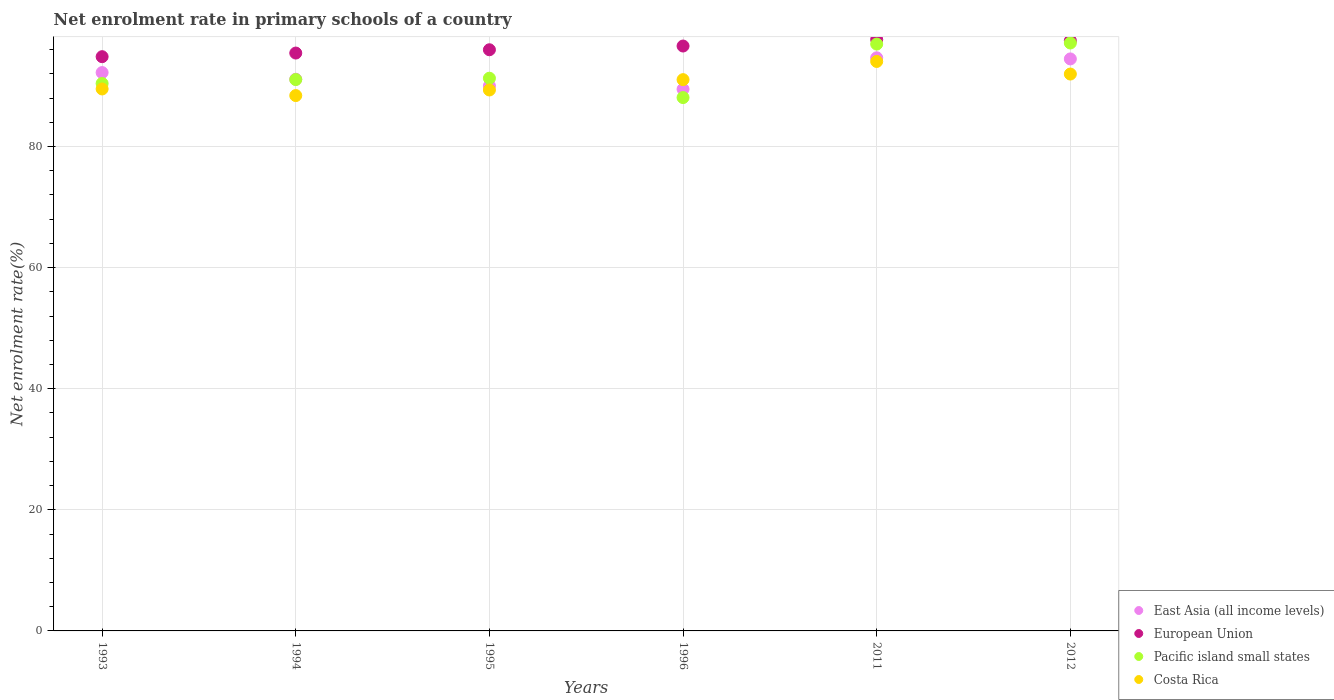Is the number of dotlines equal to the number of legend labels?
Your response must be concise. Yes. What is the net enrolment rate in primary schools in Pacific island small states in 1996?
Make the answer very short. 88.09. Across all years, what is the maximum net enrolment rate in primary schools in Costa Rica?
Your response must be concise. 94.06. Across all years, what is the minimum net enrolment rate in primary schools in European Union?
Provide a short and direct response. 94.84. In which year was the net enrolment rate in primary schools in East Asia (all income levels) maximum?
Provide a short and direct response. 2011. In which year was the net enrolment rate in primary schools in East Asia (all income levels) minimum?
Give a very brief answer. 1996. What is the total net enrolment rate in primary schools in East Asia (all income levels) in the graph?
Provide a short and direct response. 551.97. What is the difference between the net enrolment rate in primary schools in East Asia (all income levels) in 1993 and that in 2012?
Keep it short and to the point. -2.25. What is the difference between the net enrolment rate in primary schools in East Asia (all income levels) in 1993 and the net enrolment rate in primary schools in European Union in 1994?
Make the answer very short. -3.22. What is the average net enrolment rate in primary schools in East Asia (all income levels) per year?
Ensure brevity in your answer.  91.99. In the year 1996, what is the difference between the net enrolment rate in primary schools in East Asia (all income levels) and net enrolment rate in primary schools in Pacific island small states?
Give a very brief answer. 1.38. What is the ratio of the net enrolment rate in primary schools in East Asia (all income levels) in 1996 to that in 2011?
Give a very brief answer. 0.95. Is the net enrolment rate in primary schools in Costa Rica in 1993 less than that in 1994?
Provide a short and direct response. No. Is the difference between the net enrolment rate in primary schools in East Asia (all income levels) in 1993 and 1994 greater than the difference between the net enrolment rate in primary schools in Pacific island small states in 1993 and 1994?
Make the answer very short. Yes. What is the difference between the highest and the second highest net enrolment rate in primary schools in East Asia (all income levels)?
Give a very brief answer. 0.18. What is the difference between the highest and the lowest net enrolment rate in primary schools in Pacific island small states?
Provide a succinct answer. 9.01. In how many years, is the net enrolment rate in primary schools in Pacific island small states greater than the average net enrolment rate in primary schools in Pacific island small states taken over all years?
Your response must be concise. 2. Is the sum of the net enrolment rate in primary schools in Pacific island small states in 1993 and 2011 greater than the maximum net enrolment rate in primary schools in Costa Rica across all years?
Your answer should be compact. Yes. Is it the case that in every year, the sum of the net enrolment rate in primary schools in Pacific island small states and net enrolment rate in primary schools in Costa Rica  is greater than the net enrolment rate in primary schools in East Asia (all income levels)?
Your answer should be compact. Yes. Is the net enrolment rate in primary schools in European Union strictly greater than the net enrolment rate in primary schools in East Asia (all income levels) over the years?
Give a very brief answer. Yes. How many dotlines are there?
Ensure brevity in your answer.  4. Does the graph contain grids?
Make the answer very short. Yes. Where does the legend appear in the graph?
Your answer should be very brief. Bottom right. How are the legend labels stacked?
Ensure brevity in your answer.  Vertical. What is the title of the graph?
Make the answer very short. Net enrolment rate in primary schools of a country. What is the label or title of the X-axis?
Offer a terse response. Years. What is the label or title of the Y-axis?
Your answer should be compact. Net enrolment rate(%). What is the Net enrolment rate(%) of East Asia (all income levels) in 1993?
Ensure brevity in your answer.  92.22. What is the Net enrolment rate(%) in European Union in 1993?
Keep it short and to the point. 94.84. What is the Net enrolment rate(%) of Pacific island small states in 1993?
Make the answer very short. 90.42. What is the Net enrolment rate(%) in Costa Rica in 1993?
Give a very brief answer. 89.51. What is the Net enrolment rate(%) of East Asia (all income levels) in 1994?
Make the answer very short. 91.12. What is the Net enrolment rate(%) in European Union in 1994?
Provide a succinct answer. 95.44. What is the Net enrolment rate(%) in Pacific island small states in 1994?
Keep it short and to the point. 91.07. What is the Net enrolment rate(%) of Costa Rica in 1994?
Provide a succinct answer. 88.42. What is the Net enrolment rate(%) of East Asia (all income levels) in 1995?
Offer a very short reply. 90.02. What is the Net enrolment rate(%) of European Union in 1995?
Keep it short and to the point. 95.99. What is the Net enrolment rate(%) in Pacific island small states in 1995?
Keep it short and to the point. 91.29. What is the Net enrolment rate(%) in Costa Rica in 1995?
Give a very brief answer. 89.34. What is the Net enrolment rate(%) in East Asia (all income levels) in 1996?
Your answer should be very brief. 89.47. What is the Net enrolment rate(%) in European Union in 1996?
Make the answer very short. 96.6. What is the Net enrolment rate(%) in Pacific island small states in 1996?
Keep it short and to the point. 88.09. What is the Net enrolment rate(%) of Costa Rica in 1996?
Give a very brief answer. 91.05. What is the Net enrolment rate(%) in East Asia (all income levels) in 2011?
Your answer should be compact. 94.66. What is the Net enrolment rate(%) of European Union in 2011?
Keep it short and to the point. 97.69. What is the Net enrolment rate(%) in Pacific island small states in 2011?
Keep it short and to the point. 96.93. What is the Net enrolment rate(%) of Costa Rica in 2011?
Your answer should be very brief. 94.06. What is the Net enrolment rate(%) in East Asia (all income levels) in 2012?
Your answer should be very brief. 94.48. What is the Net enrolment rate(%) of European Union in 2012?
Provide a succinct answer. 97.48. What is the Net enrolment rate(%) in Pacific island small states in 2012?
Make the answer very short. 97.1. What is the Net enrolment rate(%) in Costa Rica in 2012?
Your response must be concise. 91.98. Across all years, what is the maximum Net enrolment rate(%) in East Asia (all income levels)?
Ensure brevity in your answer.  94.66. Across all years, what is the maximum Net enrolment rate(%) in European Union?
Your response must be concise. 97.69. Across all years, what is the maximum Net enrolment rate(%) of Pacific island small states?
Your answer should be compact. 97.1. Across all years, what is the maximum Net enrolment rate(%) in Costa Rica?
Make the answer very short. 94.06. Across all years, what is the minimum Net enrolment rate(%) in East Asia (all income levels)?
Keep it short and to the point. 89.47. Across all years, what is the minimum Net enrolment rate(%) of European Union?
Your answer should be compact. 94.84. Across all years, what is the minimum Net enrolment rate(%) of Pacific island small states?
Keep it short and to the point. 88.09. Across all years, what is the minimum Net enrolment rate(%) of Costa Rica?
Your answer should be very brief. 88.42. What is the total Net enrolment rate(%) in East Asia (all income levels) in the graph?
Your response must be concise. 551.97. What is the total Net enrolment rate(%) in European Union in the graph?
Provide a short and direct response. 578.04. What is the total Net enrolment rate(%) of Pacific island small states in the graph?
Offer a terse response. 554.9. What is the total Net enrolment rate(%) in Costa Rica in the graph?
Make the answer very short. 544.36. What is the difference between the Net enrolment rate(%) of East Asia (all income levels) in 1993 and that in 1994?
Ensure brevity in your answer.  1.1. What is the difference between the Net enrolment rate(%) in European Union in 1993 and that in 1994?
Keep it short and to the point. -0.6. What is the difference between the Net enrolment rate(%) of Pacific island small states in 1993 and that in 1994?
Your response must be concise. -0.65. What is the difference between the Net enrolment rate(%) of Costa Rica in 1993 and that in 1994?
Your response must be concise. 1.09. What is the difference between the Net enrolment rate(%) in European Union in 1993 and that in 1995?
Provide a succinct answer. -1.14. What is the difference between the Net enrolment rate(%) in Pacific island small states in 1993 and that in 1995?
Offer a very short reply. -0.87. What is the difference between the Net enrolment rate(%) of Costa Rica in 1993 and that in 1995?
Provide a short and direct response. 0.17. What is the difference between the Net enrolment rate(%) in East Asia (all income levels) in 1993 and that in 1996?
Provide a succinct answer. 2.75. What is the difference between the Net enrolment rate(%) of European Union in 1993 and that in 1996?
Make the answer very short. -1.76. What is the difference between the Net enrolment rate(%) in Pacific island small states in 1993 and that in 1996?
Your response must be concise. 2.33. What is the difference between the Net enrolment rate(%) of Costa Rica in 1993 and that in 1996?
Provide a succinct answer. -1.54. What is the difference between the Net enrolment rate(%) of East Asia (all income levels) in 1993 and that in 2011?
Offer a very short reply. -2.44. What is the difference between the Net enrolment rate(%) in European Union in 1993 and that in 2011?
Give a very brief answer. -2.84. What is the difference between the Net enrolment rate(%) of Pacific island small states in 1993 and that in 2011?
Your answer should be very brief. -6.51. What is the difference between the Net enrolment rate(%) of Costa Rica in 1993 and that in 2011?
Provide a short and direct response. -4.54. What is the difference between the Net enrolment rate(%) in East Asia (all income levels) in 1993 and that in 2012?
Provide a succinct answer. -2.25. What is the difference between the Net enrolment rate(%) in European Union in 1993 and that in 2012?
Provide a succinct answer. -2.64. What is the difference between the Net enrolment rate(%) in Pacific island small states in 1993 and that in 2012?
Ensure brevity in your answer.  -6.68. What is the difference between the Net enrolment rate(%) of Costa Rica in 1993 and that in 2012?
Make the answer very short. -2.46. What is the difference between the Net enrolment rate(%) of East Asia (all income levels) in 1994 and that in 1995?
Keep it short and to the point. 1.1. What is the difference between the Net enrolment rate(%) of European Union in 1994 and that in 1995?
Provide a succinct answer. -0.54. What is the difference between the Net enrolment rate(%) in Pacific island small states in 1994 and that in 1995?
Your response must be concise. -0.22. What is the difference between the Net enrolment rate(%) of Costa Rica in 1994 and that in 1995?
Offer a terse response. -0.92. What is the difference between the Net enrolment rate(%) of East Asia (all income levels) in 1994 and that in 1996?
Offer a very short reply. 1.65. What is the difference between the Net enrolment rate(%) in European Union in 1994 and that in 1996?
Keep it short and to the point. -1.16. What is the difference between the Net enrolment rate(%) in Pacific island small states in 1994 and that in 1996?
Offer a very short reply. 2.97. What is the difference between the Net enrolment rate(%) of Costa Rica in 1994 and that in 1996?
Offer a terse response. -2.63. What is the difference between the Net enrolment rate(%) in East Asia (all income levels) in 1994 and that in 2011?
Your answer should be very brief. -3.54. What is the difference between the Net enrolment rate(%) in European Union in 1994 and that in 2011?
Ensure brevity in your answer.  -2.24. What is the difference between the Net enrolment rate(%) of Pacific island small states in 1994 and that in 2011?
Your answer should be compact. -5.86. What is the difference between the Net enrolment rate(%) in Costa Rica in 1994 and that in 2011?
Provide a succinct answer. -5.63. What is the difference between the Net enrolment rate(%) in East Asia (all income levels) in 1994 and that in 2012?
Give a very brief answer. -3.35. What is the difference between the Net enrolment rate(%) of European Union in 1994 and that in 2012?
Your response must be concise. -2.04. What is the difference between the Net enrolment rate(%) of Pacific island small states in 1994 and that in 2012?
Offer a terse response. -6.04. What is the difference between the Net enrolment rate(%) of Costa Rica in 1994 and that in 2012?
Make the answer very short. -3.55. What is the difference between the Net enrolment rate(%) of East Asia (all income levels) in 1995 and that in 1996?
Ensure brevity in your answer.  0.55. What is the difference between the Net enrolment rate(%) of European Union in 1995 and that in 1996?
Provide a short and direct response. -0.62. What is the difference between the Net enrolment rate(%) of Pacific island small states in 1995 and that in 1996?
Your answer should be compact. 3.2. What is the difference between the Net enrolment rate(%) of Costa Rica in 1995 and that in 1996?
Give a very brief answer. -1.71. What is the difference between the Net enrolment rate(%) of East Asia (all income levels) in 1995 and that in 2011?
Offer a very short reply. -4.64. What is the difference between the Net enrolment rate(%) in European Union in 1995 and that in 2011?
Provide a succinct answer. -1.7. What is the difference between the Net enrolment rate(%) in Pacific island small states in 1995 and that in 2011?
Ensure brevity in your answer.  -5.64. What is the difference between the Net enrolment rate(%) of Costa Rica in 1995 and that in 2011?
Give a very brief answer. -4.71. What is the difference between the Net enrolment rate(%) in East Asia (all income levels) in 1995 and that in 2012?
Your response must be concise. -4.45. What is the difference between the Net enrolment rate(%) of European Union in 1995 and that in 2012?
Offer a terse response. -1.5. What is the difference between the Net enrolment rate(%) of Pacific island small states in 1995 and that in 2012?
Your answer should be compact. -5.82. What is the difference between the Net enrolment rate(%) of Costa Rica in 1995 and that in 2012?
Provide a short and direct response. -2.63. What is the difference between the Net enrolment rate(%) in East Asia (all income levels) in 1996 and that in 2011?
Your answer should be very brief. -5.18. What is the difference between the Net enrolment rate(%) of European Union in 1996 and that in 2011?
Offer a terse response. -1.08. What is the difference between the Net enrolment rate(%) in Pacific island small states in 1996 and that in 2011?
Ensure brevity in your answer.  -8.84. What is the difference between the Net enrolment rate(%) of Costa Rica in 1996 and that in 2011?
Offer a terse response. -3. What is the difference between the Net enrolment rate(%) of East Asia (all income levels) in 1996 and that in 2012?
Offer a very short reply. -5. What is the difference between the Net enrolment rate(%) of European Union in 1996 and that in 2012?
Ensure brevity in your answer.  -0.88. What is the difference between the Net enrolment rate(%) in Pacific island small states in 1996 and that in 2012?
Your response must be concise. -9.01. What is the difference between the Net enrolment rate(%) of Costa Rica in 1996 and that in 2012?
Make the answer very short. -0.92. What is the difference between the Net enrolment rate(%) in East Asia (all income levels) in 2011 and that in 2012?
Your answer should be very brief. 0.18. What is the difference between the Net enrolment rate(%) of European Union in 2011 and that in 2012?
Your response must be concise. 0.2. What is the difference between the Net enrolment rate(%) in Pacific island small states in 2011 and that in 2012?
Your response must be concise. -0.18. What is the difference between the Net enrolment rate(%) of Costa Rica in 2011 and that in 2012?
Your answer should be very brief. 2.08. What is the difference between the Net enrolment rate(%) in East Asia (all income levels) in 1993 and the Net enrolment rate(%) in European Union in 1994?
Provide a succinct answer. -3.22. What is the difference between the Net enrolment rate(%) in East Asia (all income levels) in 1993 and the Net enrolment rate(%) in Pacific island small states in 1994?
Your answer should be very brief. 1.16. What is the difference between the Net enrolment rate(%) in East Asia (all income levels) in 1993 and the Net enrolment rate(%) in Costa Rica in 1994?
Your answer should be very brief. 3.8. What is the difference between the Net enrolment rate(%) of European Union in 1993 and the Net enrolment rate(%) of Pacific island small states in 1994?
Ensure brevity in your answer.  3.78. What is the difference between the Net enrolment rate(%) of European Union in 1993 and the Net enrolment rate(%) of Costa Rica in 1994?
Ensure brevity in your answer.  6.42. What is the difference between the Net enrolment rate(%) of Pacific island small states in 1993 and the Net enrolment rate(%) of Costa Rica in 1994?
Provide a short and direct response. 2. What is the difference between the Net enrolment rate(%) of East Asia (all income levels) in 1993 and the Net enrolment rate(%) of European Union in 1995?
Give a very brief answer. -3.77. What is the difference between the Net enrolment rate(%) in East Asia (all income levels) in 1993 and the Net enrolment rate(%) in Pacific island small states in 1995?
Your answer should be very brief. 0.93. What is the difference between the Net enrolment rate(%) of East Asia (all income levels) in 1993 and the Net enrolment rate(%) of Costa Rica in 1995?
Give a very brief answer. 2.88. What is the difference between the Net enrolment rate(%) of European Union in 1993 and the Net enrolment rate(%) of Pacific island small states in 1995?
Ensure brevity in your answer.  3.56. What is the difference between the Net enrolment rate(%) of European Union in 1993 and the Net enrolment rate(%) of Costa Rica in 1995?
Provide a succinct answer. 5.5. What is the difference between the Net enrolment rate(%) in Pacific island small states in 1993 and the Net enrolment rate(%) in Costa Rica in 1995?
Keep it short and to the point. 1.08. What is the difference between the Net enrolment rate(%) in East Asia (all income levels) in 1993 and the Net enrolment rate(%) in European Union in 1996?
Keep it short and to the point. -4.38. What is the difference between the Net enrolment rate(%) in East Asia (all income levels) in 1993 and the Net enrolment rate(%) in Pacific island small states in 1996?
Offer a terse response. 4.13. What is the difference between the Net enrolment rate(%) of East Asia (all income levels) in 1993 and the Net enrolment rate(%) of Costa Rica in 1996?
Ensure brevity in your answer.  1.17. What is the difference between the Net enrolment rate(%) in European Union in 1993 and the Net enrolment rate(%) in Pacific island small states in 1996?
Offer a very short reply. 6.75. What is the difference between the Net enrolment rate(%) of European Union in 1993 and the Net enrolment rate(%) of Costa Rica in 1996?
Ensure brevity in your answer.  3.79. What is the difference between the Net enrolment rate(%) of Pacific island small states in 1993 and the Net enrolment rate(%) of Costa Rica in 1996?
Provide a succinct answer. -0.63. What is the difference between the Net enrolment rate(%) of East Asia (all income levels) in 1993 and the Net enrolment rate(%) of European Union in 2011?
Provide a short and direct response. -5.46. What is the difference between the Net enrolment rate(%) in East Asia (all income levels) in 1993 and the Net enrolment rate(%) in Pacific island small states in 2011?
Give a very brief answer. -4.71. What is the difference between the Net enrolment rate(%) in East Asia (all income levels) in 1993 and the Net enrolment rate(%) in Costa Rica in 2011?
Give a very brief answer. -1.83. What is the difference between the Net enrolment rate(%) in European Union in 1993 and the Net enrolment rate(%) in Pacific island small states in 2011?
Give a very brief answer. -2.08. What is the difference between the Net enrolment rate(%) in European Union in 1993 and the Net enrolment rate(%) in Costa Rica in 2011?
Provide a short and direct response. 0.79. What is the difference between the Net enrolment rate(%) in Pacific island small states in 1993 and the Net enrolment rate(%) in Costa Rica in 2011?
Provide a succinct answer. -3.64. What is the difference between the Net enrolment rate(%) in East Asia (all income levels) in 1993 and the Net enrolment rate(%) in European Union in 2012?
Provide a succinct answer. -5.26. What is the difference between the Net enrolment rate(%) of East Asia (all income levels) in 1993 and the Net enrolment rate(%) of Pacific island small states in 2012?
Make the answer very short. -4.88. What is the difference between the Net enrolment rate(%) of East Asia (all income levels) in 1993 and the Net enrolment rate(%) of Costa Rica in 2012?
Offer a very short reply. 0.24. What is the difference between the Net enrolment rate(%) of European Union in 1993 and the Net enrolment rate(%) of Pacific island small states in 2012?
Offer a terse response. -2.26. What is the difference between the Net enrolment rate(%) of European Union in 1993 and the Net enrolment rate(%) of Costa Rica in 2012?
Your answer should be compact. 2.87. What is the difference between the Net enrolment rate(%) in Pacific island small states in 1993 and the Net enrolment rate(%) in Costa Rica in 2012?
Your answer should be very brief. -1.56. What is the difference between the Net enrolment rate(%) in East Asia (all income levels) in 1994 and the Net enrolment rate(%) in European Union in 1995?
Provide a short and direct response. -4.87. What is the difference between the Net enrolment rate(%) in East Asia (all income levels) in 1994 and the Net enrolment rate(%) in Pacific island small states in 1995?
Your answer should be very brief. -0.17. What is the difference between the Net enrolment rate(%) of East Asia (all income levels) in 1994 and the Net enrolment rate(%) of Costa Rica in 1995?
Provide a succinct answer. 1.78. What is the difference between the Net enrolment rate(%) in European Union in 1994 and the Net enrolment rate(%) in Pacific island small states in 1995?
Give a very brief answer. 4.16. What is the difference between the Net enrolment rate(%) in European Union in 1994 and the Net enrolment rate(%) in Costa Rica in 1995?
Give a very brief answer. 6.1. What is the difference between the Net enrolment rate(%) of Pacific island small states in 1994 and the Net enrolment rate(%) of Costa Rica in 1995?
Provide a succinct answer. 1.72. What is the difference between the Net enrolment rate(%) of East Asia (all income levels) in 1994 and the Net enrolment rate(%) of European Union in 1996?
Give a very brief answer. -5.48. What is the difference between the Net enrolment rate(%) of East Asia (all income levels) in 1994 and the Net enrolment rate(%) of Pacific island small states in 1996?
Your response must be concise. 3.03. What is the difference between the Net enrolment rate(%) of East Asia (all income levels) in 1994 and the Net enrolment rate(%) of Costa Rica in 1996?
Provide a short and direct response. 0.07. What is the difference between the Net enrolment rate(%) of European Union in 1994 and the Net enrolment rate(%) of Pacific island small states in 1996?
Offer a terse response. 7.35. What is the difference between the Net enrolment rate(%) in European Union in 1994 and the Net enrolment rate(%) in Costa Rica in 1996?
Offer a very short reply. 4.39. What is the difference between the Net enrolment rate(%) in Pacific island small states in 1994 and the Net enrolment rate(%) in Costa Rica in 1996?
Your response must be concise. 0.01. What is the difference between the Net enrolment rate(%) in East Asia (all income levels) in 1994 and the Net enrolment rate(%) in European Union in 2011?
Make the answer very short. -6.56. What is the difference between the Net enrolment rate(%) in East Asia (all income levels) in 1994 and the Net enrolment rate(%) in Pacific island small states in 2011?
Your answer should be very brief. -5.81. What is the difference between the Net enrolment rate(%) in East Asia (all income levels) in 1994 and the Net enrolment rate(%) in Costa Rica in 2011?
Give a very brief answer. -2.93. What is the difference between the Net enrolment rate(%) of European Union in 1994 and the Net enrolment rate(%) of Pacific island small states in 2011?
Offer a terse response. -1.48. What is the difference between the Net enrolment rate(%) in European Union in 1994 and the Net enrolment rate(%) in Costa Rica in 2011?
Provide a short and direct response. 1.39. What is the difference between the Net enrolment rate(%) of Pacific island small states in 1994 and the Net enrolment rate(%) of Costa Rica in 2011?
Your response must be concise. -2.99. What is the difference between the Net enrolment rate(%) of East Asia (all income levels) in 1994 and the Net enrolment rate(%) of European Union in 2012?
Keep it short and to the point. -6.36. What is the difference between the Net enrolment rate(%) in East Asia (all income levels) in 1994 and the Net enrolment rate(%) in Pacific island small states in 2012?
Keep it short and to the point. -5.98. What is the difference between the Net enrolment rate(%) in East Asia (all income levels) in 1994 and the Net enrolment rate(%) in Costa Rica in 2012?
Your answer should be compact. -0.85. What is the difference between the Net enrolment rate(%) of European Union in 1994 and the Net enrolment rate(%) of Pacific island small states in 2012?
Give a very brief answer. -1.66. What is the difference between the Net enrolment rate(%) in European Union in 1994 and the Net enrolment rate(%) in Costa Rica in 2012?
Ensure brevity in your answer.  3.47. What is the difference between the Net enrolment rate(%) of Pacific island small states in 1994 and the Net enrolment rate(%) of Costa Rica in 2012?
Provide a short and direct response. -0.91. What is the difference between the Net enrolment rate(%) in East Asia (all income levels) in 1995 and the Net enrolment rate(%) in European Union in 1996?
Give a very brief answer. -6.58. What is the difference between the Net enrolment rate(%) in East Asia (all income levels) in 1995 and the Net enrolment rate(%) in Pacific island small states in 1996?
Your response must be concise. 1.93. What is the difference between the Net enrolment rate(%) of East Asia (all income levels) in 1995 and the Net enrolment rate(%) of Costa Rica in 1996?
Your response must be concise. -1.03. What is the difference between the Net enrolment rate(%) in European Union in 1995 and the Net enrolment rate(%) in Pacific island small states in 1996?
Provide a succinct answer. 7.9. What is the difference between the Net enrolment rate(%) in European Union in 1995 and the Net enrolment rate(%) in Costa Rica in 1996?
Your answer should be compact. 4.94. What is the difference between the Net enrolment rate(%) in Pacific island small states in 1995 and the Net enrolment rate(%) in Costa Rica in 1996?
Ensure brevity in your answer.  0.24. What is the difference between the Net enrolment rate(%) in East Asia (all income levels) in 1995 and the Net enrolment rate(%) in European Union in 2011?
Provide a short and direct response. -7.66. What is the difference between the Net enrolment rate(%) in East Asia (all income levels) in 1995 and the Net enrolment rate(%) in Pacific island small states in 2011?
Keep it short and to the point. -6.91. What is the difference between the Net enrolment rate(%) of East Asia (all income levels) in 1995 and the Net enrolment rate(%) of Costa Rica in 2011?
Ensure brevity in your answer.  -4.04. What is the difference between the Net enrolment rate(%) in European Union in 1995 and the Net enrolment rate(%) in Pacific island small states in 2011?
Your answer should be very brief. -0.94. What is the difference between the Net enrolment rate(%) in European Union in 1995 and the Net enrolment rate(%) in Costa Rica in 2011?
Your answer should be very brief. 1.93. What is the difference between the Net enrolment rate(%) of Pacific island small states in 1995 and the Net enrolment rate(%) of Costa Rica in 2011?
Give a very brief answer. -2.77. What is the difference between the Net enrolment rate(%) in East Asia (all income levels) in 1995 and the Net enrolment rate(%) in European Union in 2012?
Make the answer very short. -7.46. What is the difference between the Net enrolment rate(%) of East Asia (all income levels) in 1995 and the Net enrolment rate(%) of Pacific island small states in 2012?
Offer a terse response. -7.08. What is the difference between the Net enrolment rate(%) in East Asia (all income levels) in 1995 and the Net enrolment rate(%) in Costa Rica in 2012?
Keep it short and to the point. -1.96. What is the difference between the Net enrolment rate(%) of European Union in 1995 and the Net enrolment rate(%) of Pacific island small states in 2012?
Give a very brief answer. -1.12. What is the difference between the Net enrolment rate(%) in European Union in 1995 and the Net enrolment rate(%) in Costa Rica in 2012?
Provide a short and direct response. 4.01. What is the difference between the Net enrolment rate(%) in Pacific island small states in 1995 and the Net enrolment rate(%) in Costa Rica in 2012?
Your answer should be very brief. -0.69. What is the difference between the Net enrolment rate(%) in East Asia (all income levels) in 1996 and the Net enrolment rate(%) in European Union in 2011?
Provide a short and direct response. -8.21. What is the difference between the Net enrolment rate(%) in East Asia (all income levels) in 1996 and the Net enrolment rate(%) in Pacific island small states in 2011?
Your response must be concise. -7.45. What is the difference between the Net enrolment rate(%) in East Asia (all income levels) in 1996 and the Net enrolment rate(%) in Costa Rica in 2011?
Ensure brevity in your answer.  -4.58. What is the difference between the Net enrolment rate(%) of European Union in 1996 and the Net enrolment rate(%) of Pacific island small states in 2011?
Give a very brief answer. -0.32. What is the difference between the Net enrolment rate(%) of European Union in 1996 and the Net enrolment rate(%) of Costa Rica in 2011?
Make the answer very short. 2.55. What is the difference between the Net enrolment rate(%) of Pacific island small states in 1996 and the Net enrolment rate(%) of Costa Rica in 2011?
Your answer should be compact. -5.96. What is the difference between the Net enrolment rate(%) in East Asia (all income levels) in 1996 and the Net enrolment rate(%) in European Union in 2012?
Provide a succinct answer. -8.01. What is the difference between the Net enrolment rate(%) in East Asia (all income levels) in 1996 and the Net enrolment rate(%) in Pacific island small states in 2012?
Offer a very short reply. -7.63. What is the difference between the Net enrolment rate(%) of East Asia (all income levels) in 1996 and the Net enrolment rate(%) of Costa Rica in 2012?
Your response must be concise. -2.5. What is the difference between the Net enrolment rate(%) of European Union in 1996 and the Net enrolment rate(%) of Pacific island small states in 2012?
Provide a succinct answer. -0.5. What is the difference between the Net enrolment rate(%) of European Union in 1996 and the Net enrolment rate(%) of Costa Rica in 2012?
Your answer should be very brief. 4.63. What is the difference between the Net enrolment rate(%) of Pacific island small states in 1996 and the Net enrolment rate(%) of Costa Rica in 2012?
Make the answer very short. -3.88. What is the difference between the Net enrolment rate(%) in East Asia (all income levels) in 2011 and the Net enrolment rate(%) in European Union in 2012?
Give a very brief answer. -2.83. What is the difference between the Net enrolment rate(%) in East Asia (all income levels) in 2011 and the Net enrolment rate(%) in Pacific island small states in 2012?
Your answer should be very brief. -2.45. What is the difference between the Net enrolment rate(%) in East Asia (all income levels) in 2011 and the Net enrolment rate(%) in Costa Rica in 2012?
Offer a very short reply. 2.68. What is the difference between the Net enrolment rate(%) in European Union in 2011 and the Net enrolment rate(%) in Pacific island small states in 2012?
Your answer should be compact. 0.58. What is the difference between the Net enrolment rate(%) in European Union in 2011 and the Net enrolment rate(%) in Costa Rica in 2012?
Provide a succinct answer. 5.71. What is the difference between the Net enrolment rate(%) of Pacific island small states in 2011 and the Net enrolment rate(%) of Costa Rica in 2012?
Offer a terse response. 4.95. What is the average Net enrolment rate(%) in East Asia (all income levels) per year?
Your answer should be compact. 91.99. What is the average Net enrolment rate(%) in European Union per year?
Provide a short and direct response. 96.34. What is the average Net enrolment rate(%) of Pacific island small states per year?
Your answer should be compact. 92.48. What is the average Net enrolment rate(%) of Costa Rica per year?
Provide a short and direct response. 90.73. In the year 1993, what is the difference between the Net enrolment rate(%) of East Asia (all income levels) and Net enrolment rate(%) of European Union?
Offer a terse response. -2.62. In the year 1993, what is the difference between the Net enrolment rate(%) in East Asia (all income levels) and Net enrolment rate(%) in Pacific island small states?
Provide a succinct answer. 1.8. In the year 1993, what is the difference between the Net enrolment rate(%) in East Asia (all income levels) and Net enrolment rate(%) in Costa Rica?
Make the answer very short. 2.71. In the year 1993, what is the difference between the Net enrolment rate(%) of European Union and Net enrolment rate(%) of Pacific island small states?
Your response must be concise. 4.42. In the year 1993, what is the difference between the Net enrolment rate(%) of European Union and Net enrolment rate(%) of Costa Rica?
Your answer should be very brief. 5.33. In the year 1993, what is the difference between the Net enrolment rate(%) of Pacific island small states and Net enrolment rate(%) of Costa Rica?
Provide a short and direct response. 0.91. In the year 1994, what is the difference between the Net enrolment rate(%) of East Asia (all income levels) and Net enrolment rate(%) of European Union?
Ensure brevity in your answer.  -4.32. In the year 1994, what is the difference between the Net enrolment rate(%) in East Asia (all income levels) and Net enrolment rate(%) in Pacific island small states?
Your response must be concise. 0.06. In the year 1994, what is the difference between the Net enrolment rate(%) of East Asia (all income levels) and Net enrolment rate(%) of Costa Rica?
Provide a succinct answer. 2.7. In the year 1994, what is the difference between the Net enrolment rate(%) in European Union and Net enrolment rate(%) in Pacific island small states?
Your answer should be very brief. 4.38. In the year 1994, what is the difference between the Net enrolment rate(%) of European Union and Net enrolment rate(%) of Costa Rica?
Offer a very short reply. 7.02. In the year 1994, what is the difference between the Net enrolment rate(%) in Pacific island small states and Net enrolment rate(%) in Costa Rica?
Make the answer very short. 2.64. In the year 1995, what is the difference between the Net enrolment rate(%) in East Asia (all income levels) and Net enrolment rate(%) in European Union?
Your response must be concise. -5.97. In the year 1995, what is the difference between the Net enrolment rate(%) in East Asia (all income levels) and Net enrolment rate(%) in Pacific island small states?
Provide a succinct answer. -1.27. In the year 1995, what is the difference between the Net enrolment rate(%) of East Asia (all income levels) and Net enrolment rate(%) of Costa Rica?
Keep it short and to the point. 0.68. In the year 1995, what is the difference between the Net enrolment rate(%) of European Union and Net enrolment rate(%) of Pacific island small states?
Keep it short and to the point. 4.7. In the year 1995, what is the difference between the Net enrolment rate(%) in European Union and Net enrolment rate(%) in Costa Rica?
Ensure brevity in your answer.  6.64. In the year 1995, what is the difference between the Net enrolment rate(%) in Pacific island small states and Net enrolment rate(%) in Costa Rica?
Offer a very short reply. 1.94. In the year 1996, what is the difference between the Net enrolment rate(%) in East Asia (all income levels) and Net enrolment rate(%) in European Union?
Make the answer very short. -7.13. In the year 1996, what is the difference between the Net enrolment rate(%) of East Asia (all income levels) and Net enrolment rate(%) of Pacific island small states?
Make the answer very short. 1.38. In the year 1996, what is the difference between the Net enrolment rate(%) in East Asia (all income levels) and Net enrolment rate(%) in Costa Rica?
Offer a very short reply. -1.58. In the year 1996, what is the difference between the Net enrolment rate(%) of European Union and Net enrolment rate(%) of Pacific island small states?
Make the answer very short. 8.51. In the year 1996, what is the difference between the Net enrolment rate(%) of European Union and Net enrolment rate(%) of Costa Rica?
Your answer should be compact. 5.55. In the year 1996, what is the difference between the Net enrolment rate(%) of Pacific island small states and Net enrolment rate(%) of Costa Rica?
Provide a succinct answer. -2.96. In the year 2011, what is the difference between the Net enrolment rate(%) of East Asia (all income levels) and Net enrolment rate(%) of European Union?
Provide a short and direct response. -3.03. In the year 2011, what is the difference between the Net enrolment rate(%) of East Asia (all income levels) and Net enrolment rate(%) of Pacific island small states?
Offer a terse response. -2.27. In the year 2011, what is the difference between the Net enrolment rate(%) in East Asia (all income levels) and Net enrolment rate(%) in Costa Rica?
Offer a terse response. 0.6. In the year 2011, what is the difference between the Net enrolment rate(%) of European Union and Net enrolment rate(%) of Pacific island small states?
Offer a terse response. 0.76. In the year 2011, what is the difference between the Net enrolment rate(%) of European Union and Net enrolment rate(%) of Costa Rica?
Ensure brevity in your answer.  3.63. In the year 2011, what is the difference between the Net enrolment rate(%) of Pacific island small states and Net enrolment rate(%) of Costa Rica?
Provide a short and direct response. 2.87. In the year 2012, what is the difference between the Net enrolment rate(%) in East Asia (all income levels) and Net enrolment rate(%) in European Union?
Your response must be concise. -3.01. In the year 2012, what is the difference between the Net enrolment rate(%) of East Asia (all income levels) and Net enrolment rate(%) of Pacific island small states?
Your answer should be very brief. -2.63. In the year 2012, what is the difference between the Net enrolment rate(%) in East Asia (all income levels) and Net enrolment rate(%) in Costa Rica?
Offer a terse response. 2.5. In the year 2012, what is the difference between the Net enrolment rate(%) in European Union and Net enrolment rate(%) in Pacific island small states?
Offer a very short reply. 0.38. In the year 2012, what is the difference between the Net enrolment rate(%) of European Union and Net enrolment rate(%) of Costa Rica?
Give a very brief answer. 5.51. In the year 2012, what is the difference between the Net enrolment rate(%) of Pacific island small states and Net enrolment rate(%) of Costa Rica?
Your answer should be very brief. 5.13. What is the ratio of the Net enrolment rate(%) in East Asia (all income levels) in 1993 to that in 1994?
Keep it short and to the point. 1.01. What is the ratio of the Net enrolment rate(%) in European Union in 1993 to that in 1994?
Provide a short and direct response. 0.99. What is the ratio of the Net enrolment rate(%) of Costa Rica in 1993 to that in 1994?
Your answer should be compact. 1.01. What is the ratio of the Net enrolment rate(%) of East Asia (all income levels) in 1993 to that in 1995?
Ensure brevity in your answer.  1.02. What is the ratio of the Net enrolment rate(%) of East Asia (all income levels) in 1993 to that in 1996?
Your answer should be very brief. 1.03. What is the ratio of the Net enrolment rate(%) of European Union in 1993 to that in 1996?
Provide a succinct answer. 0.98. What is the ratio of the Net enrolment rate(%) in Pacific island small states in 1993 to that in 1996?
Ensure brevity in your answer.  1.03. What is the ratio of the Net enrolment rate(%) of Costa Rica in 1993 to that in 1996?
Ensure brevity in your answer.  0.98. What is the ratio of the Net enrolment rate(%) in East Asia (all income levels) in 1993 to that in 2011?
Provide a short and direct response. 0.97. What is the ratio of the Net enrolment rate(%) of European Union in 1993 to that in 2011?
Offer a terse response. 0.97. What is the ratio of the Net enrolment rate(%) of Pacific island small states in 1993 to that in 2011?
Offer a terse response. 0.93. What is the ratio of the Net enrolment rate(%) in Costa Rica in 1993 to that in 2011?
Your response must be concise. 0.95. What is the ratio of the Net enrolment rate(%) of East Asia (all income levels) in 1993 to that in 2012?
Make the answer very short. 0.98. What is the ratio of the Net enrolment rate(%) in European Union in 1993 to that in 2012?
Make the answer very short. 0.97. What is the ratio of the Net enrolment rate(%) of Pacific island small states in 1993 to that in 2012?
Provide a short and direct response. 0.93. What is the ratio of the Net enrolment rate(%) in Costa Rica in 1993 to that in 2012?
Give a very brief answer. 0.97. What is the ratio of the Net enrolment rate(%) in East Asia (all income levels) in 1994 to that in 1995?
Provide a short and direct response. 1.01. What is the ratio of the Net enrolment rate(%) in European Union in 1994 to that in 1995?
Your answer should be compact. 0.99. What is the ratio of the Net enrolment rate(%) of Pacific island small states in 1994 to that in 1995?
Your answer should be compact. 1. What is the ratio of the Net enrolment rate(%) in Costa Rica in 1994 to that in 1995?
Offer a terse response. 0.99. What is the ratio of the Net enrolment rate(%) in East Asia (all income levels) in 1994 to that in 1996?
Give a very brief answer. 1.02. What is the ratio of the Net enrolment rate(%) in Pacific island small states in 1994 to that in 1996?
Your answer should be very brief. 1.03. What is the ratio of the Net enrolment rate(%) of Costa Rica in 1994 to that in 1996?
Offer a terse response. 0.97. What is the ratio of the Net enrolment rate(%) of East Asia (all income levels) in 1994 to that in 2011?
Your answer should be compact. 0.96. What is the ratio of the Net enrolment rate(%) in Pacific island small states in 1994 to that in 2011?
Your answer should be compact. 0.94. What is the ratio of the Net enrolment rate(%) of Costa Rica in 1994 to that in 2011?
Keep it short and to the point. 0.94. What is the ratio of the Net enrolment rate(%) of East Asia (all income levels) in 1994 to that in 2012?
Your response must be concise. 0.96. What is the ratio of the Net enrolment rate(%) in European Union in 1994 to that in 2012?
Ensure brevity in your answer.  0.98. What is the ratio of the Net enrolment rate(%) in Pacific island small states in 1994 to that in 2012?
Offer a terse response. 0.94. What is the ratio of the Net enrolment rate(%) of Costa Rica in 1994 to that in 2012?
Your answer should be very brief. 0.96. What is the ratio of the Net enrolment rate(%) of European Union in 1995 to that in 1996?
Your response must be concise. 0.99. What is the ratio of the Net enrolment rate(%) in Pacific island small states in 1995 to that in 1996?
Keep it short and to the point. 1.04. What is the ratio of the Net enrolment rate(%) of Costa Rica in 1995 to that in 1996?
Offer a very short reply. 0.98. What is the ratio of the Net enrolment rate(%) in East Asia (all income levels) in 1995 to that in 2011?
Make the answer very short. 0.95. What is the ratio of the Net enrolment rate(%) in European Union in 1995 to that in 2011?
Give a very brief answer. 0.98. What is the ratio of the Net enrolment rate(%) of Pacific island small states in 1995 to that in 2011?
Your answer should be very brief. 0.94. What is the ratio of the Net enrolment rate(%) in Costa Rica in 1995 to that in 2011?
Your response must be concise. 0.95. What is the ratio of the Net enrolment rate(%) in East Asia (all income levels) in 1995 to that in 2012?
Offer a terse response. 0.95. What is the ratio of the Net enrolment rate(%) in European Union in 1995 to that in 2012?
Offer a terse response. 0.98. What is the ratio of the Net enrolment rate(%) in Pacific island small states in 1995 to that in 2012?
Ensure brevity in your answer.  0.94. What is the ratio of the Net enrolment rate(%) in Costa Rica in 1995 to that in 2012?
Your answer should be very brief. 0.97. What is the ratio of the Net enrolment rate(%) in East Asia (all income levels) in 1996 to that in 2011?
Your answer should be compact. 0.95. What is the ratio of the Net enrolment rate(%) of European Union in 1996 to that in 2011?
Keep it short and to the point. 0.99. What is the ratio of the Net enrolment rate(%) of Pacific island small states in 1996 to that in 2011?
Keep it short and to the point. 0.91. What is the ratio of the Net enrolment rate(%) in Costa Rica in 1996 to that in 2011?
Your response must be concise. 0.97. What is the ratio of the Net enrolment rate(%) in East Asia (all income levels) in 1996 to that in 2012?
Your answer should be very brief. 0.95. What is the ratio of the Net enrolment rate(%) of Pacific island small states in 1996 to that in 2012?
Your answer should be very brief. 0.91. What is the ratio of the Net enrolment rate(%) in Costa Rica in 1996 to that in 2012?
Provide a short and direct response. 0.99. What is the ratio of the Net enrolment rate(%) in East Asia (all income levels) in 2011 to that in 2012?
Offer a very short reply. 1. What is the ratio of the Net enrolment rate(%) in Pacific island small states in 2011 to that in 2012?
Your response must be concise. 1. What is the ratio of the Net enrolment rate(%) in Costa Rica in 2011 to that in 2012?
Your answer should be compact. 1.02. What is the difference between the highest and the second highest Net enrolment rate(%) of East Asia (all income levels)?
Offer a terse response. 0.18. What is the difference between the highest and the second highest Net enrolment rate(%) of European Union?
Offer a very short reply. 0.2. What is the difference between the highest and the second highest Net enrolment rate(%) in Pacific island small states?
Your response must be concise. 0.18. What is the difference between the highest and the second highest Net enrolment rate(%) in Costa Rica?
Offer a terse response. 2.08. What is the difference between the highest and the lowest Net enrolment rate(%) of East Asia (all income levels)?
Provide a succinct answer. 5.18. What is the difference between the highest and the lowest Net enrolment rate(%) of European Union?
Make the answer very short. 2.84. What is the difference between the highest and the lowest Net enrolment rate(%) of Pacific island small states?
Your answer should be very brief. 9.01. What is the difference between the highest and the lowest Net enrolment rate(%) in Costa Rica?
Your answer should be very brief. 5.63. 